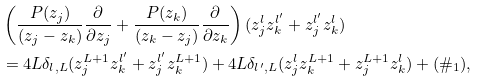Convert formula to latex. <formula><loc_0><loc_0><loc_500><loc_500>& \left ( \frac { P ( z _ { j } ) } { ( z _ { j } - z _ { k } ) } \frac { \partial } { \partial z _ { j } } + \frac { P ( z _ { k } ) } { ( z _ { k } - z _ { j } ) } \frac { \partial } { \partial z _ { k } } \right ) ( z _ { j } ^ { l } z _ { k } ^ { l ^ { \prime } } + z _ { j } ^ { l ^ { \prime } } z _ { k } ^ { l } ) \\ & = 4 L \delta _ { l , L } ( z _ { j } ^ { L + 1 } z _ { k } ^ { l ^ { \prime } } + z _ { j } ^ { l ^ { \prime } } z _ { k } ^ { L + 1 } ) + 4 L \delta _ { l ^ { \prime } , L } ( z _ { j } ^ { l } z _ { k } ^ { L + 1 } + z _ { j } ^ { L + 1 } z _ { k } ^ { l } ) + ( \# _ { 1 } ) ,</formula> 